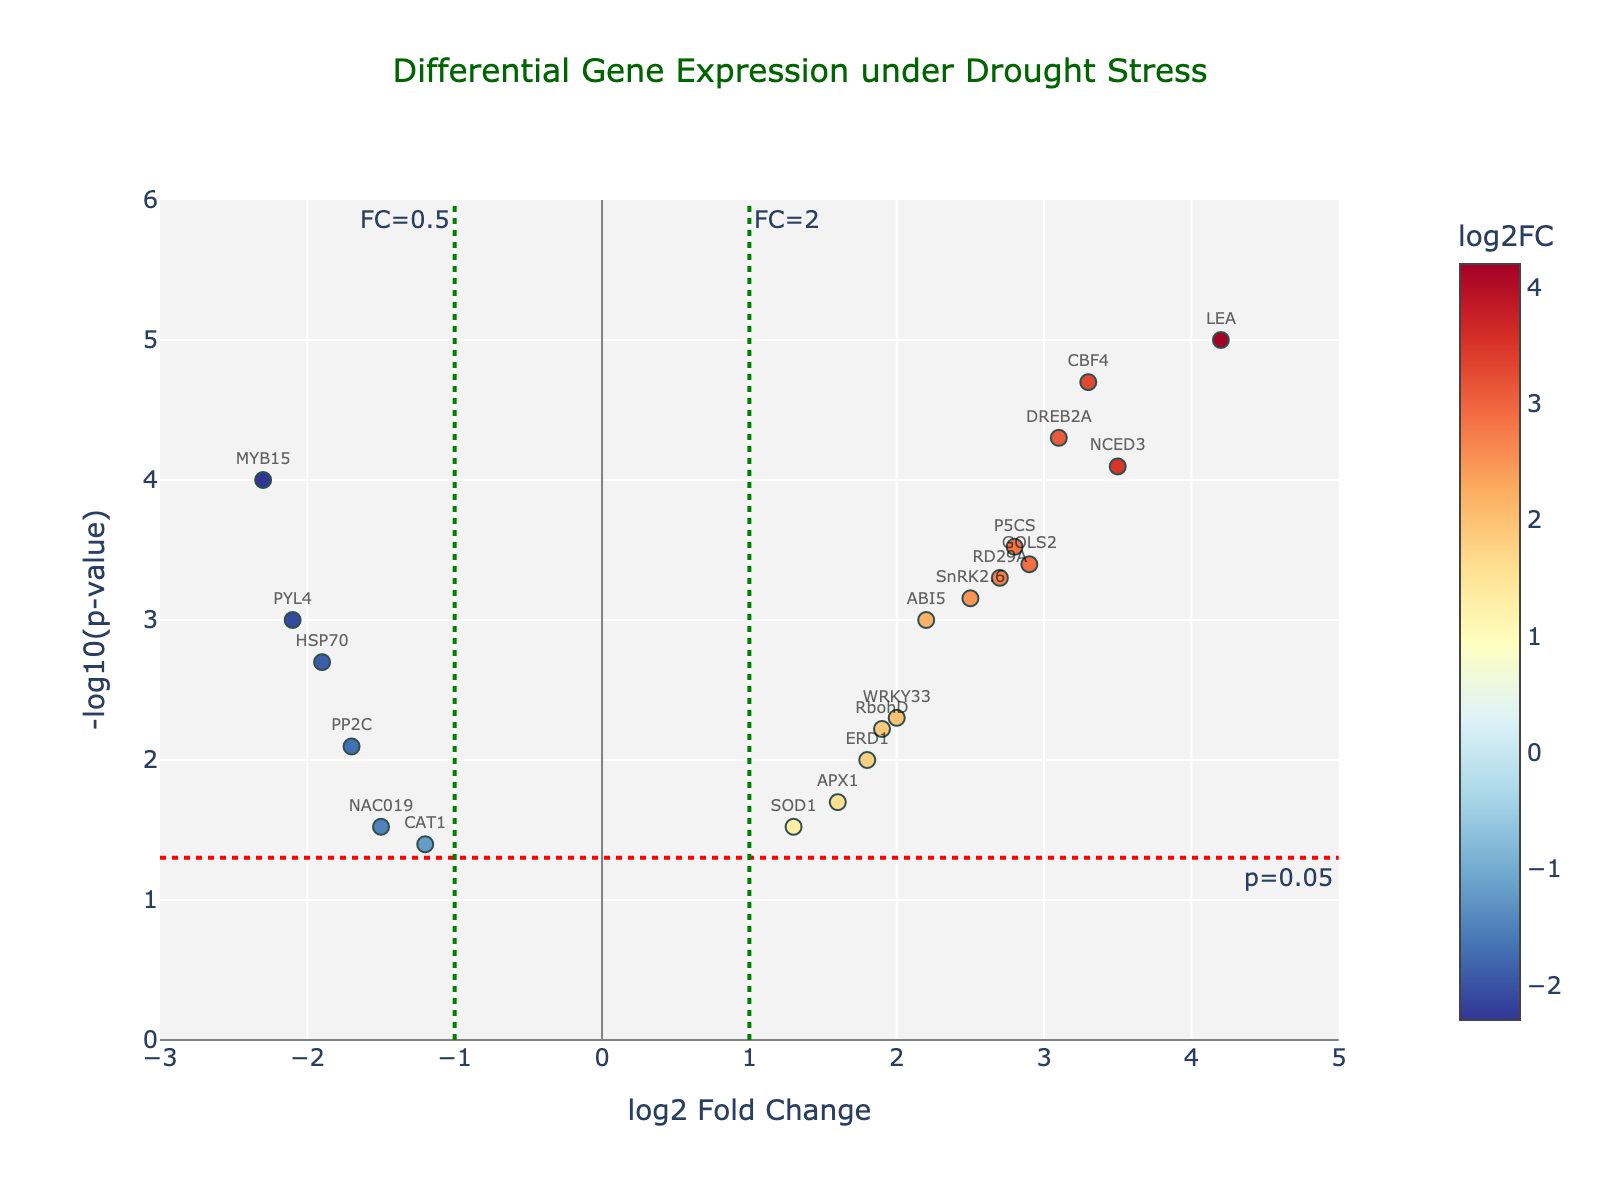What is the title of the plot? The plot displays a title at the top center which reads "Differential Gene Expression under Drought Stress."
Answer: Differential Gene Expression under Drought Stress What does the x-axis represent in the Volcano Plot? The label under the x-axis indicates that it represents the "log2 Fold Change," showing how much a gene's expression has changed under drought stress.
Answer: log2 Fold Change Which gene has the highest expression fold change according to the plot? By observing the x-axis for the maximum value, the gene "LEA" shows the highest log2 Fold Change value at 4.2.
Answer: LEA How many genes show a statistically significant change with a p-value less than 0.05? By identifying the points above the horizontal dotted line (indicating p=0.05), we count the genes. There are 17 such genes above this threshold.
Answer: 17 Which gene has the lowest p-value? The lowest p-value corresponds to the highest -log10(p-value) on the y-axis. The gene "LEA" reaches the highest on this axis, implying the smallest p-value of 0.00001.
Answer: LEA What does the color of the data points represent? By observing the colorbar linked to the colors of the data points on the right side of the plot, it indicates that the colors represent the "log2 Fold Change" values.
Answer: log2 Fold Change Among the highly induced genes (log2FC > 2), which gene has the highest p-value? For genes with a log2 Fold Change greater than 2, we look at the -log10(p-value) value on the y-axis and identify "RD29A" as having a relatively low -log10(p-value), translating to the highest p-value in this set.
Answer: RD29A Compare the gene MYB15 and DREB2A in terms of fold changes and significance. Which is more significant? MYB15 has a log2 Fold Change of -2.3 and p-value of 0.0001 while DREB2A has a log2 Fold Change of 3.1 and p-value of 0.00005. DREB2A is more significant, shown by a lower p-value (higher -log10(p-value)).
Answer: DREB2A Which of the less expressed genes (log2FC < -1) is the least significant? Observing the genes below -1 on the x-axis for their heights on the y-axis, "CAT1" with log2FC -1.2 and p-value 0.04 is the lowest on the y-axis, indicating the least significant p-value in this group.
Answer: CAT1 Is there any gene with a log2 Fold Change close to 0? Checking the values near 0 on the x-axis, there are no genes with a log2 Fold Change close to 0 in the given data set.
Answer: No 